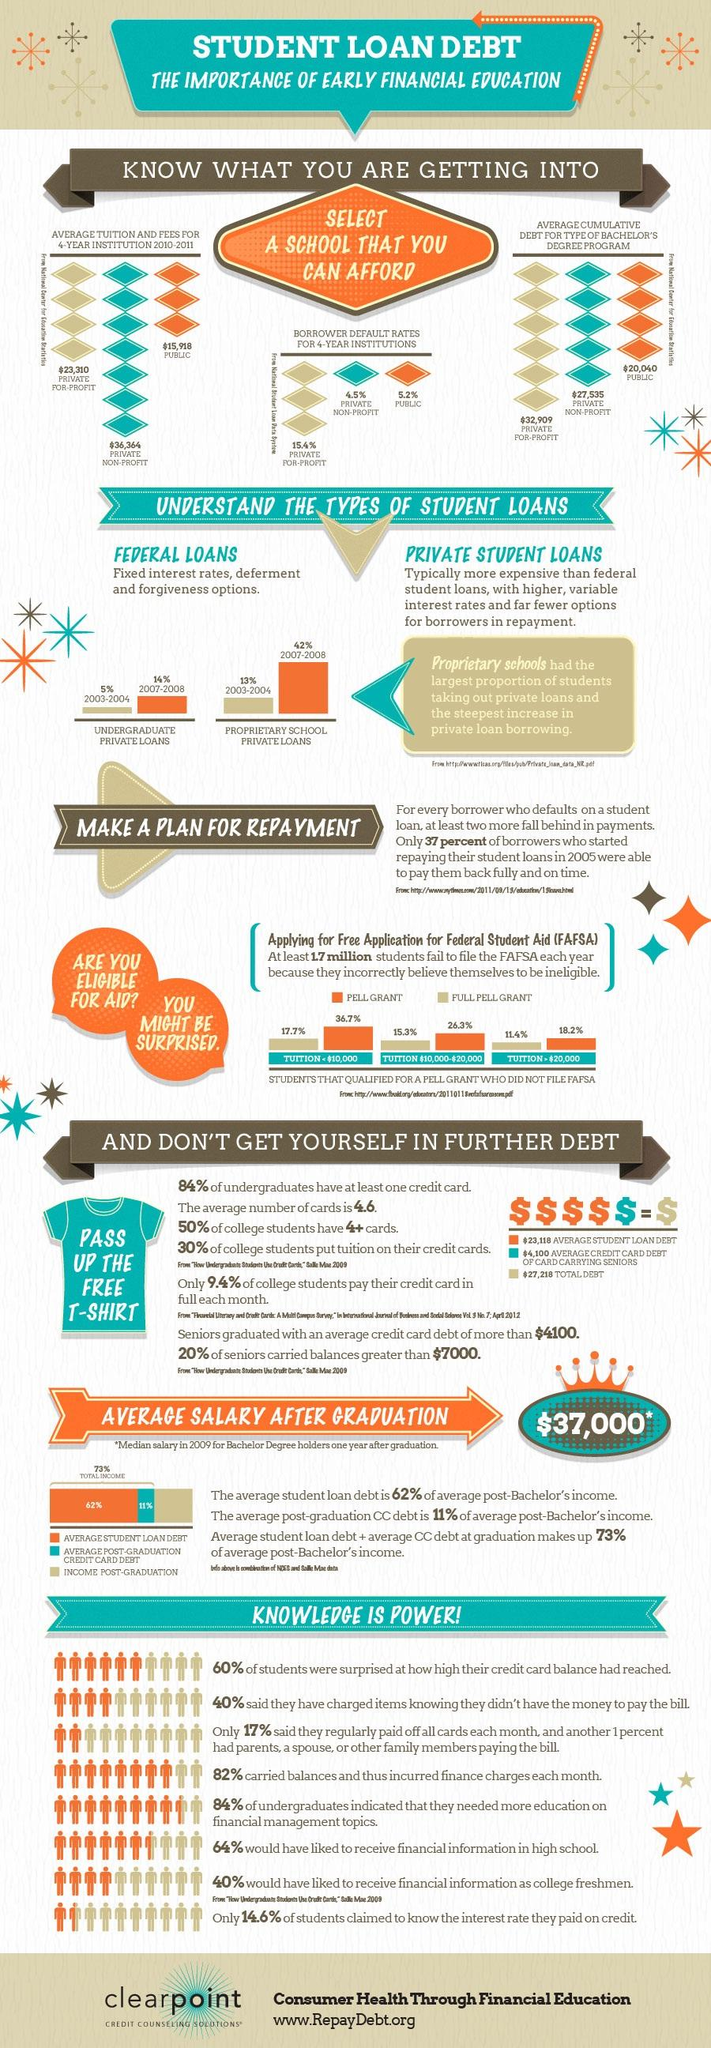Draw attention to some important aspects in this diagram. There are two types of student loans mentioned in this infographic. 